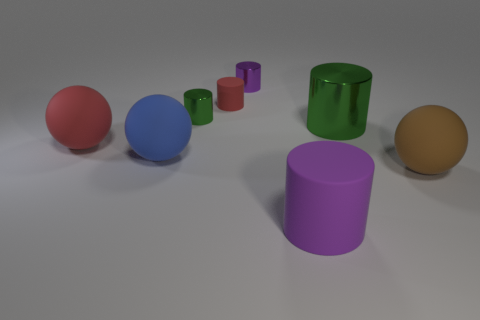Are there the same number of tiny purple metallic cylinders behind the brown matte ball and large blue rubber objects left of the small matte object?
Provide a short and direct response. Yes. There is a purple object that is in front of the red rubber ball; what material is it?
Provide a succinct answer. Rubber. Is the number of metal objects less than the number of big shiny objects?
Make the answer very short. No. What shape is the metallic thing that is in front of the purple metallic object and behind the big green object?
Give a very brief answer. Cylinder. How many big shiny cylinders are there?
Give a very brief answer. 1. There is a purple object that is in front of the large red sphere that is behind the rubber sphere that is in front of the large blue ball; what is it made of?
Your response must be concise. Rubber. How many green shiny cylinders are in front of the purple cylinder in front of the red rubber cylinder?
Provide a short and direct response. 0. The tiny rubber thing that is the same shape as the large metal thing is what color?
Give a very brief answer. Red. Are the large green thing and the small purple object made of the same material?
Your answer should be compact. Yes. How many spheres are matte objects or tiny green objects?
Your answer should be compact. 3. 